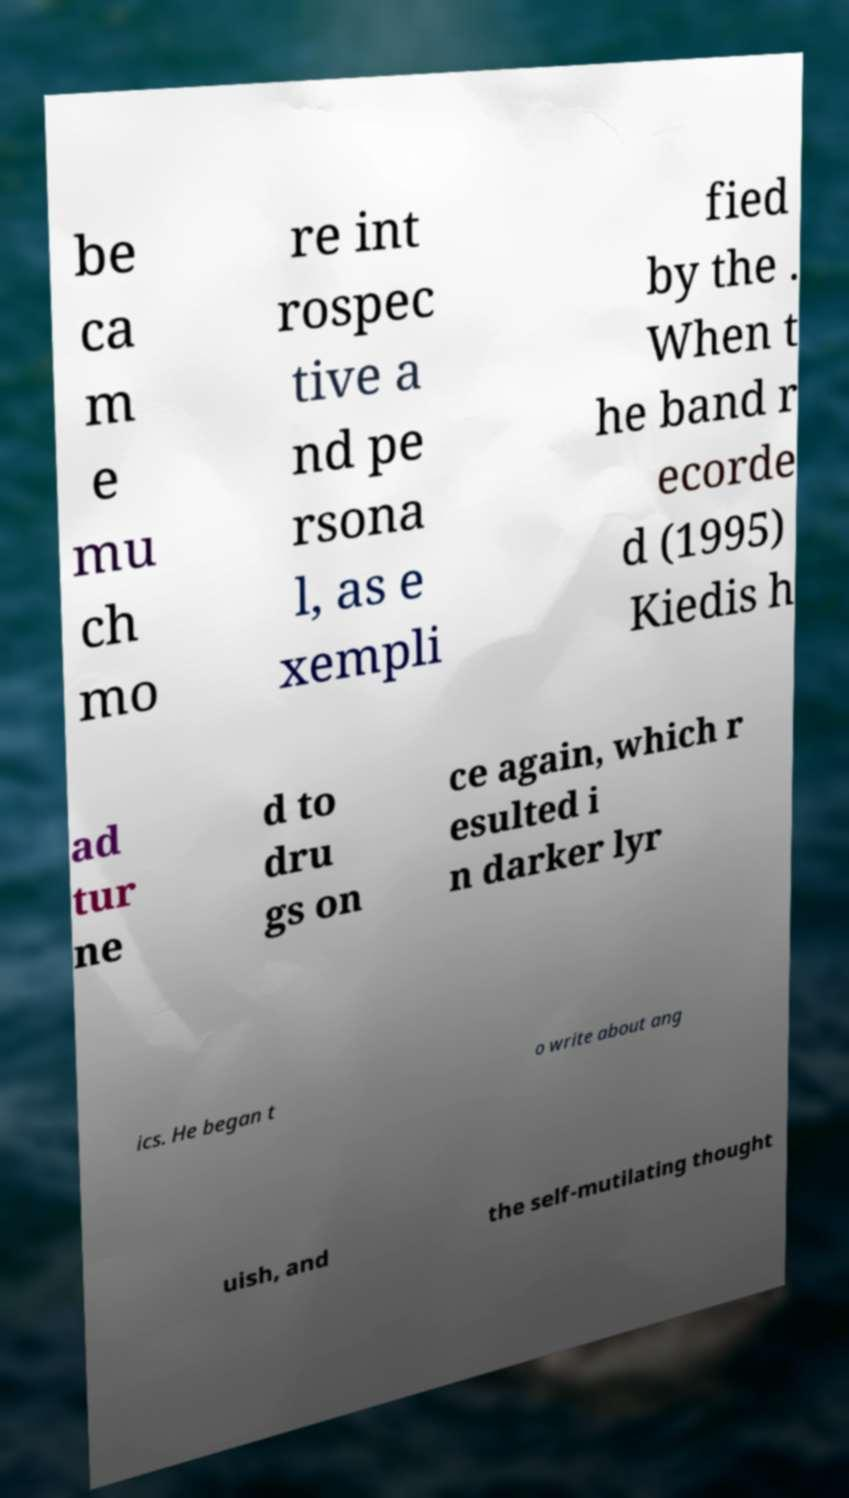Please read and relay the text visible in this image. What does it say? be ca m e mu ch mo re int rospec tive a nd pe rsona l, as e xempli fied by the . When t he band r ecorde d (1995) Kiedis h ad tur ne d to dru gs on ce again, which r esulted i n darker lyr ics. He began t o write about ang uish, and the self-mutilating thought 